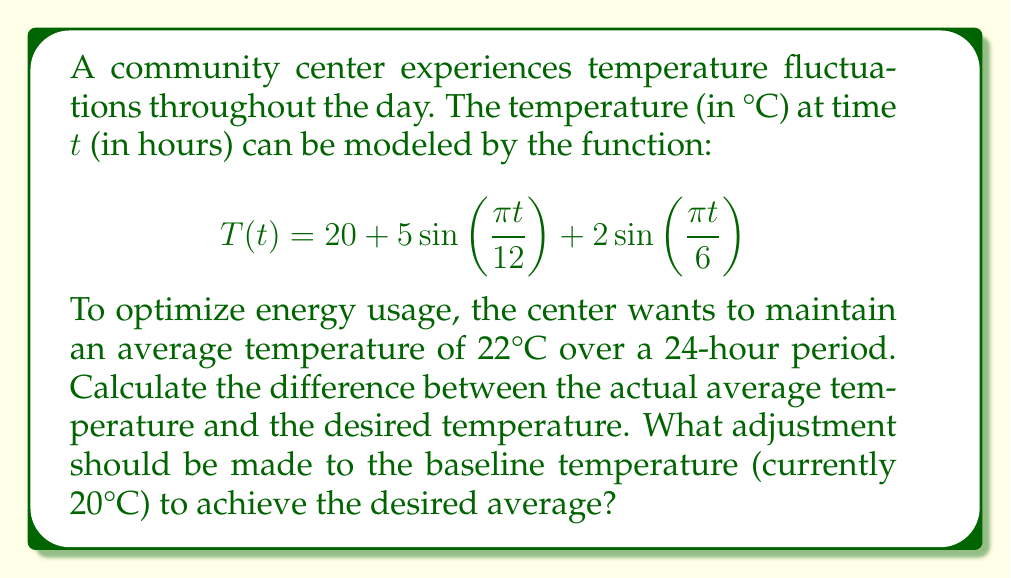Can you solve this math problem? 1) To find the average temperature, we need to integrate the function over 24 hours and divide by 24:

   $$\text{Average} = \frac{1}{24}\int_0^{24} T(t) dt$$

2) Let's break down the integral:

   $$\frac{1}{24}\int_0^{24} (20 + 5\sin(\frac{\pi t}{12}) + 2\sin(\frac{\pi t}{6})) dt$$

3) Integrate each term:
   
   - $\frac{1}{24}\int_0^{24} 20 dt = 20$
   
   - $\frac{1}{24}\int_0^{24} 5\sin(\frac{\pi t}{12}) dt = \frac{5}{24}[-\frac{12}{\pi}\cos(\frac{\pi t}{12})]_0^{24} = 0$
   
   - $\frac{1}{24}\int_0^{24} 2\sin(\frac{\pi t}{6}) dt = \frac{2}{24}[-\frac{6}{\pi}\cos(\frac{\pi t}{6})]_0^{24} = 0$

4) The average temperature is 20°C.

5) The difference between the actual average and desired average:
   
   $22°C - 20°C = 2°C$

6) To achieve the desired average, we need to increase the baseline temperature by 2°C.

   New baseline: $20°C + 2°C = 22°C$

7) The adjusted temperature function would be:

   $$T(t) = 22 + 5\sin(\frac{\pi t}{12}) + 2\sin(\frac{\pi t}{6})$$
Answer: Increase baseline by 2°C 